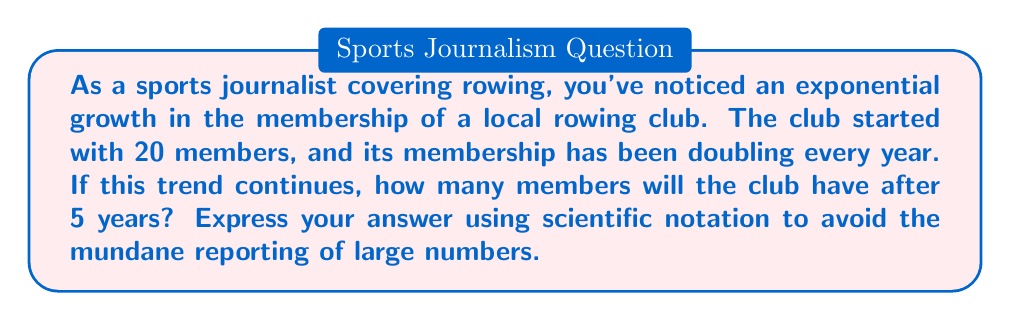What is the answer to this math problem? Let's approach this step-by-step:

1) The initial number of members is 20.

2) The membership doubles every year, which means we're dealing with exponential growth with a base of 2.

3) The exponential growth formula is:

   $$ A = P \cdot r^t $$

   Where:
   $A$ is the final amount
   $P$ is the initial amount (principal)
   $r$ is the growth rate (in this case, 2 for doubling)
   $t$ is the time period (5 years)

4) Plugging in our values:

   $$ A = 20 \cdot 2^5 $$

5) Now let's calculate:

   $$ A = 20 \cdot 32 = 640 $$

6) To express this in scientific notation (as per our journalistic style to avoid boring large numbers):

   $$ 640 = 6.4 \times 10^2 $$

This exponential growth showcases the explosive popularity of rowing, far outpacing the linear growth seen in many other, less exciting sports.
Answer: $6.4 \times 10^2$ members 